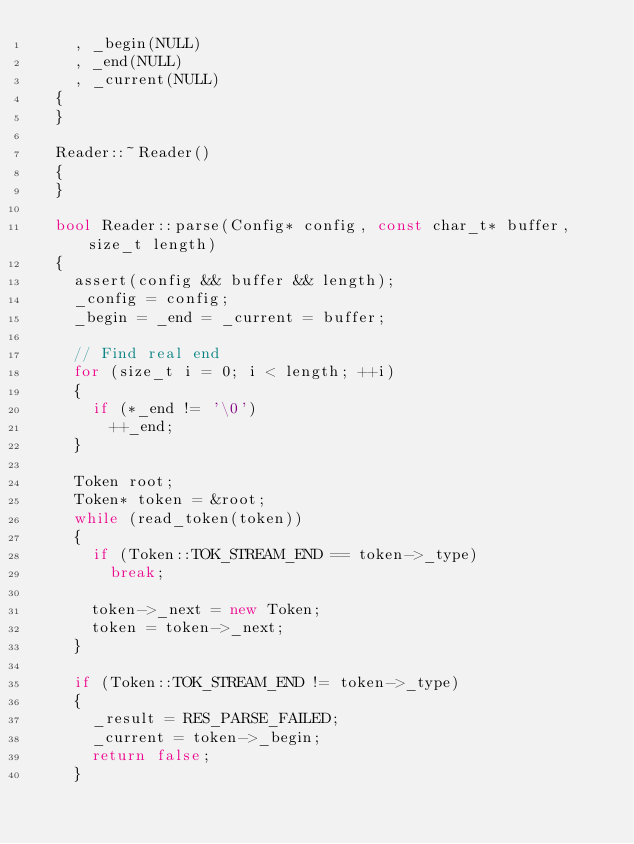Convert code to text. <code><loc_0><loc_0><loc_500><loc_500><_C++_>		, _begin(NULL)
		, _end(NULL)
		, _current(NULL)
	{
	}

	Reader::~Reader()
	{
	}

	bool Reader::parse(Config* config, const char_t* buffer, size_t length)
	{
		assert(config && buffer && length);
		_config = config;
		_begin = _end = _current = buffer;

		// Find real end
		for (size_t i = 0; i < length; ++i)
		{
			if (*_end != '\0')
				++_end;
		}

		Token root;
		Token* token = &root;
		while (read_token(token))
		{
			if (Token::TOK_STREAM_END == token->_type)
				break;

			token->_next = new Token;
			token = token->_next;
		}

		if (Token::TOK_STREAM_END != token->_type)
		{
			_result = RES_PARSE_FAILED;
			_current = token->_begin;
			return false;
		}
</code> 